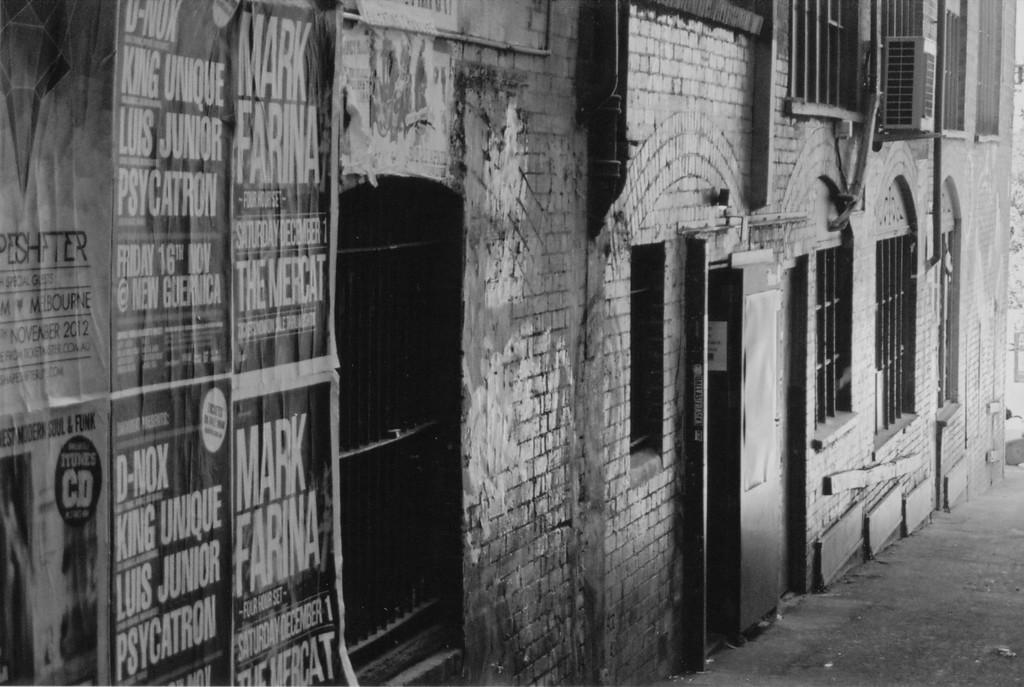What is the main structure visible in the image? There is a wall in the image. What features can be seen on the wall? The wall has windows and posters attached to it. What type of landscape is visible at the right bottom of the image? The image shows land at the right bottom. How many toes can be seen on the island in the image? There is no island or toes present in the image. What type of sport is being played on the baseball field in the image? There is no baseball field or sport being played in the image. 